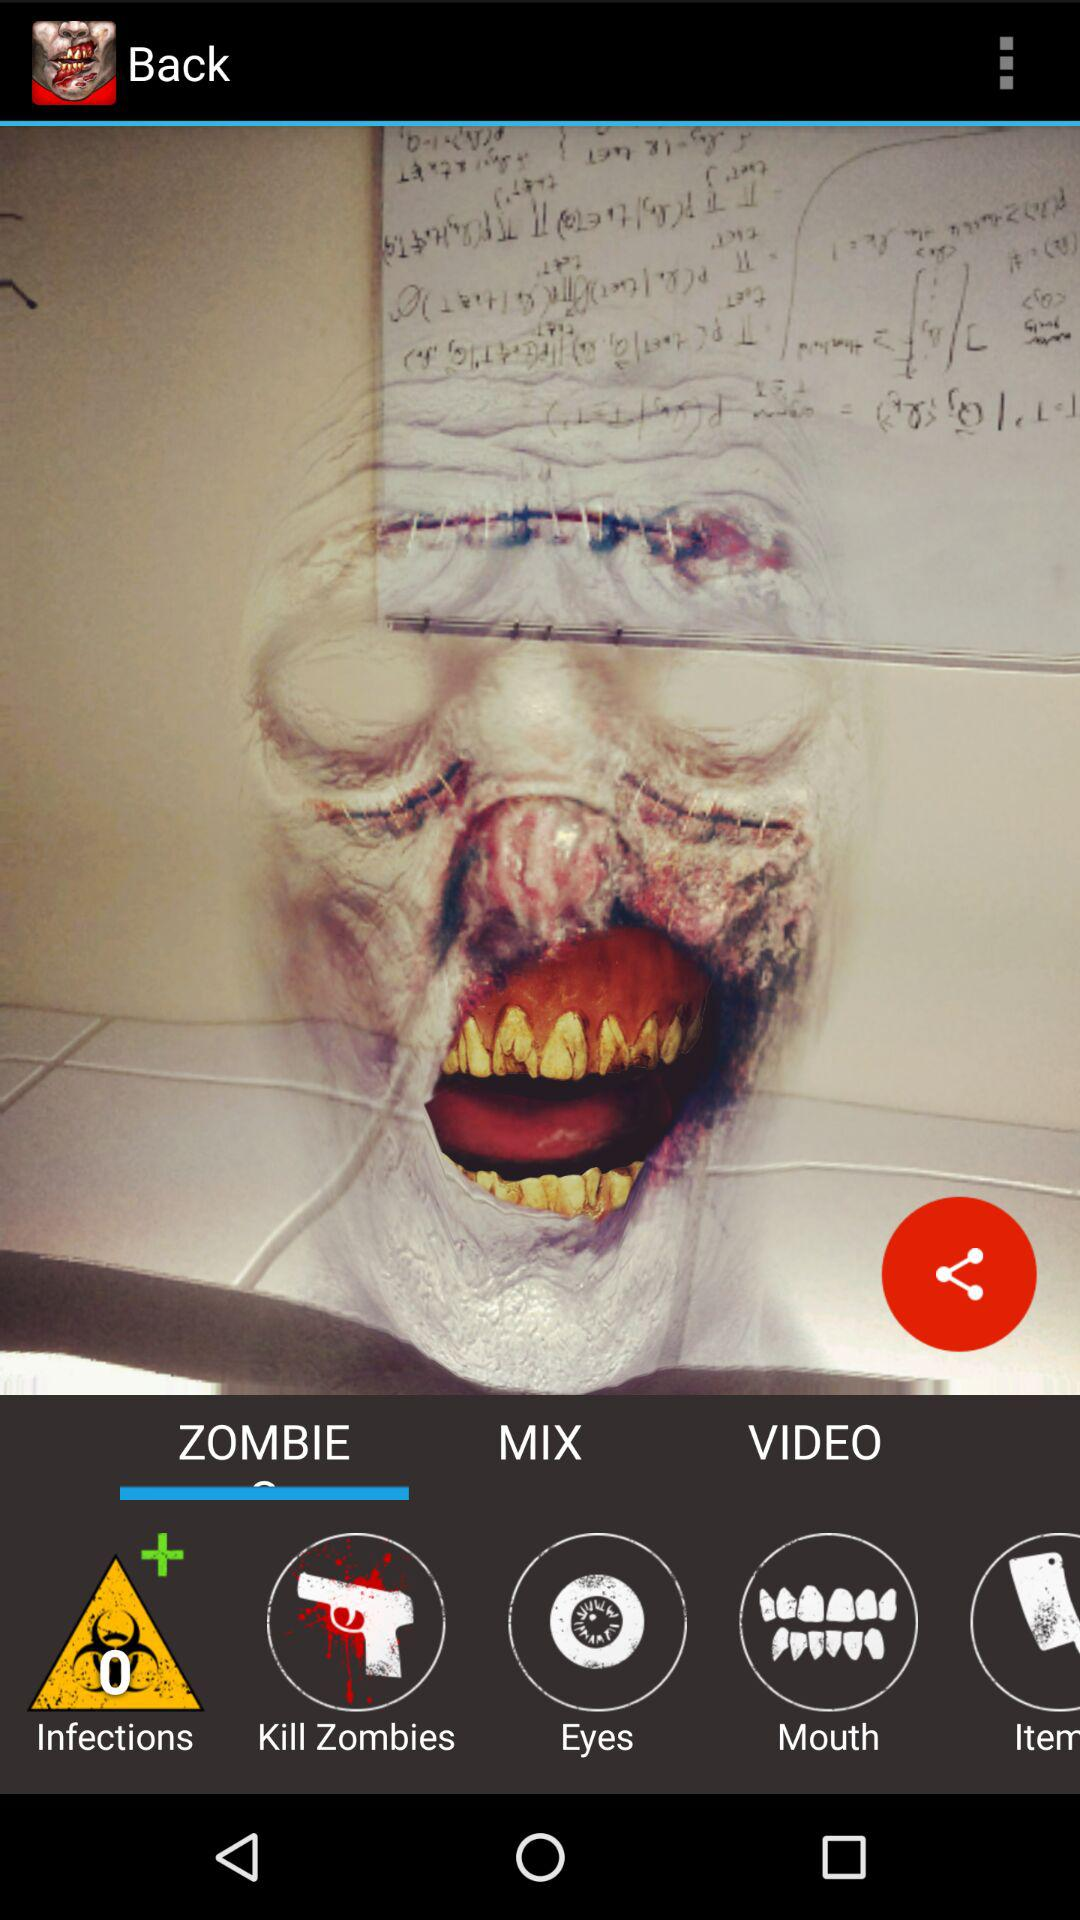How many videos are there?
When the provided information is insufficient, respond with <no answer>. <no answer> 